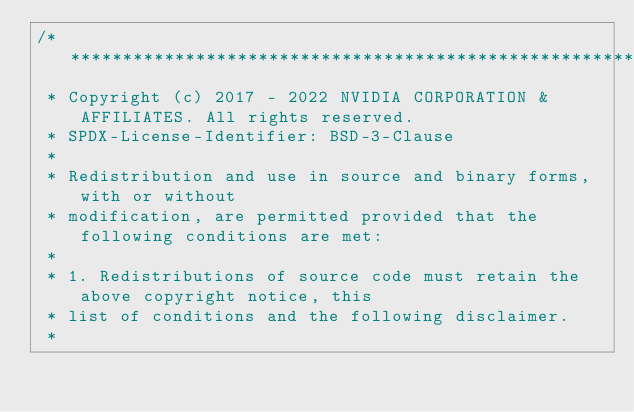<code> <loc_0><loc_0><loc_500><loc_500><_Cuda_>/***************************************************************************************************
 * Copyright (c) 2017 - 2022 NVIDIA CORPORATION & AFFILIATES. All rights reserved.
 * SPDX-License-Identifier: BSD-3-Clause
 *
 * Redistribution and use in source and binary forms, with or without
 * modification, are permitted provided that the following conditions are met:
 *
 * 1. Redistributions of source code must retain the above copyright notice, this
 * list of conditions and the following disclaimer.
 *</code> 